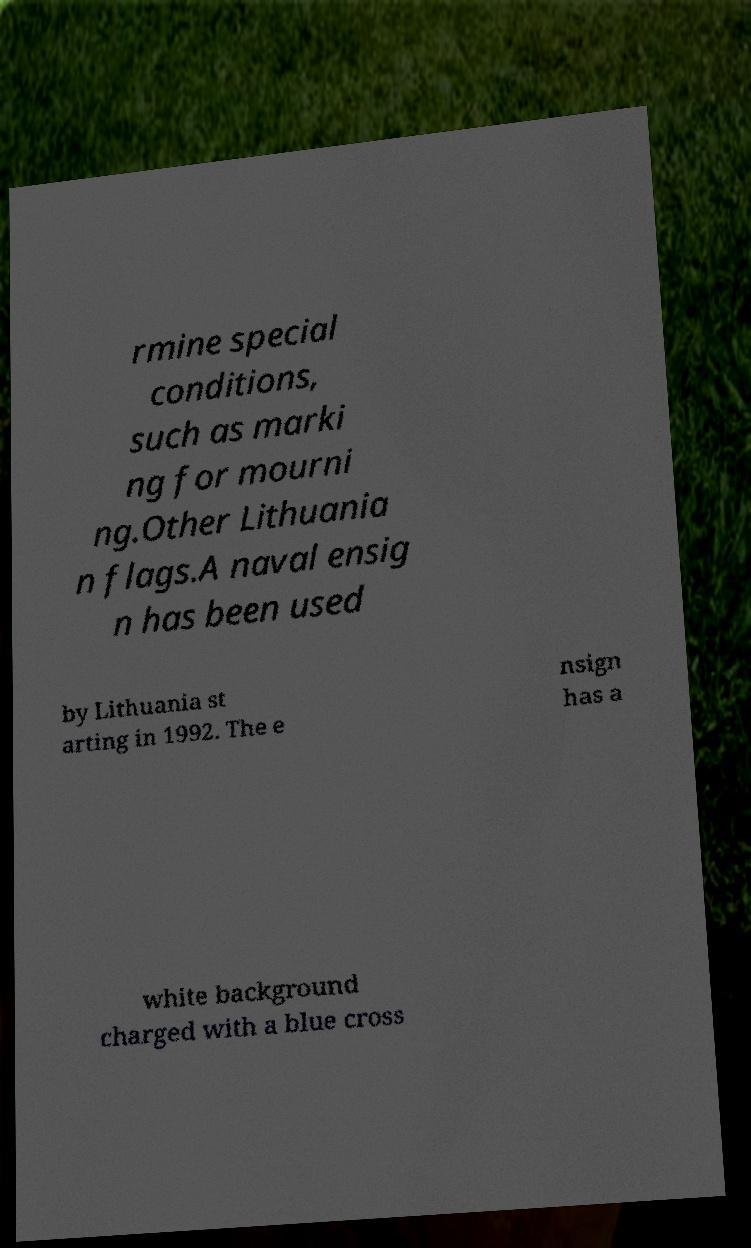Please read and relay the text visible in this image. What does it say? rmine special conditions, such as marki ng for mourni ng.Other Lithuania n flags.A naval ensig n has been used by Lithuania st arting in 1992. The e nsign has a white background charged with a blue cross 